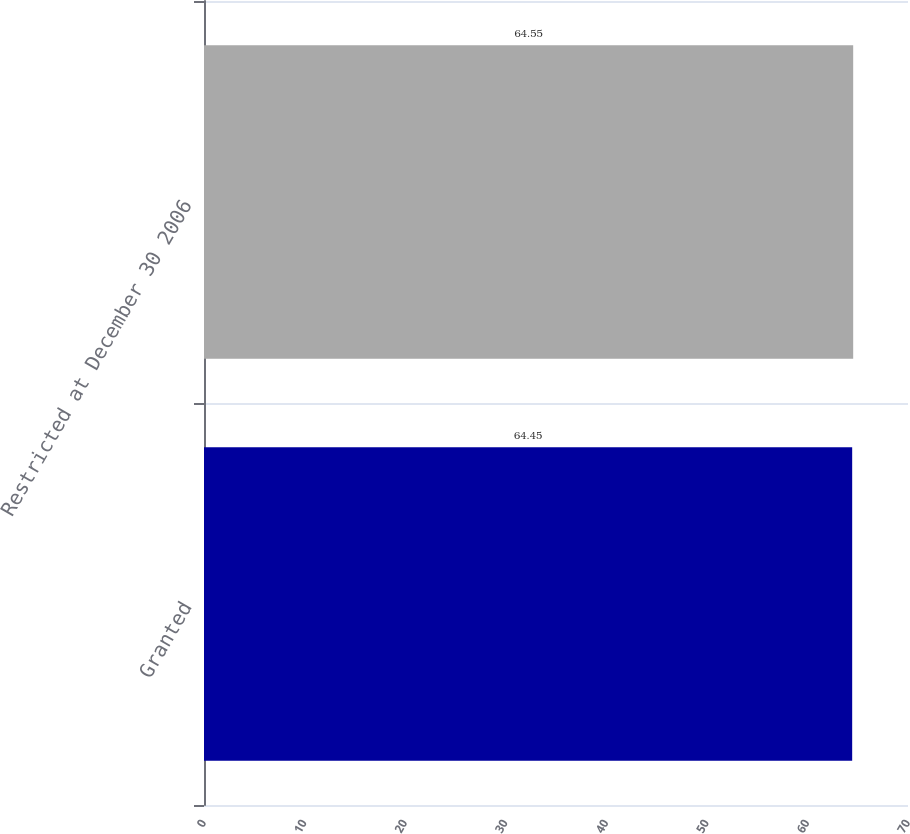Convert chart to OTSL. <chart><loc_0><loc_0><loc_500><loc_500><bar_chart><fcel>Granted<fcel>Restricted at December 30 2006<nl><fcel>64.45<fcel>64.55<nl></chart> 